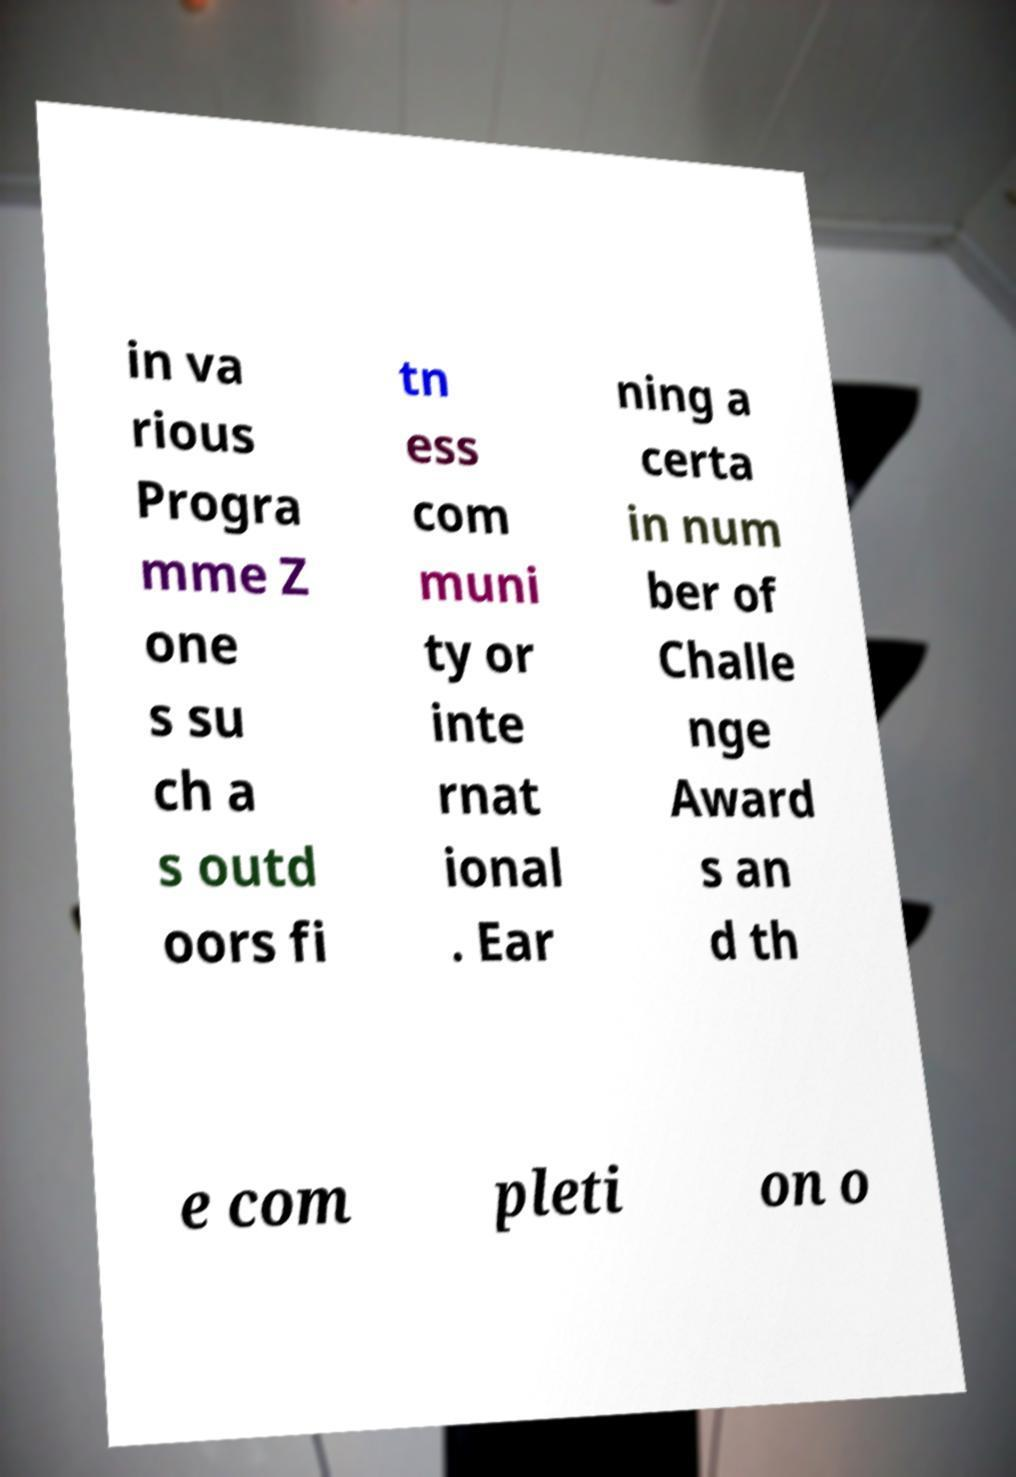There's text embedded in this image that I need extracted. Can you transcribe it verbatim? in va rious Progra mme Z one s su ch a s outd oors fi tn ess com muni ty or inte rnat ional . Ear ning a certa in num ber of Challe nge Award s an d th e com pleti on o 